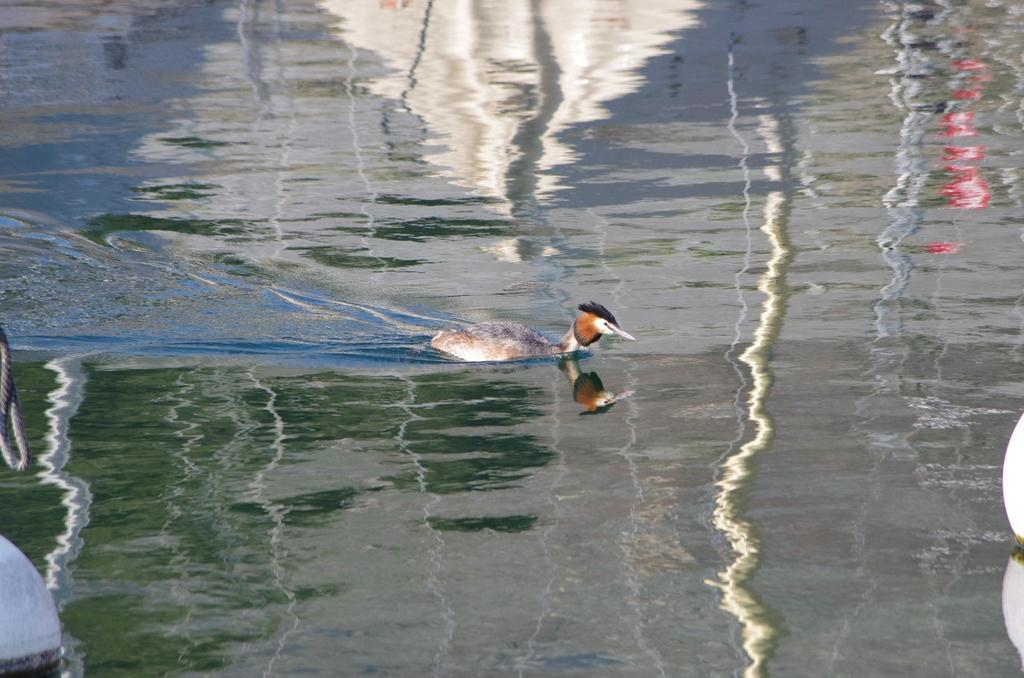What animal is in the foreground of the image? There is a duck in the foreground of the image. Where is the duck located? The duck is in the water. What can be seen on either side of the image? There are lights on either side of the image. What object is on the left side of the image? There is a rope on the left side of the image. What type of protest is taking place in the image? There is no protest present in the image; it features a duck in the water with lights and a rope on either side. 